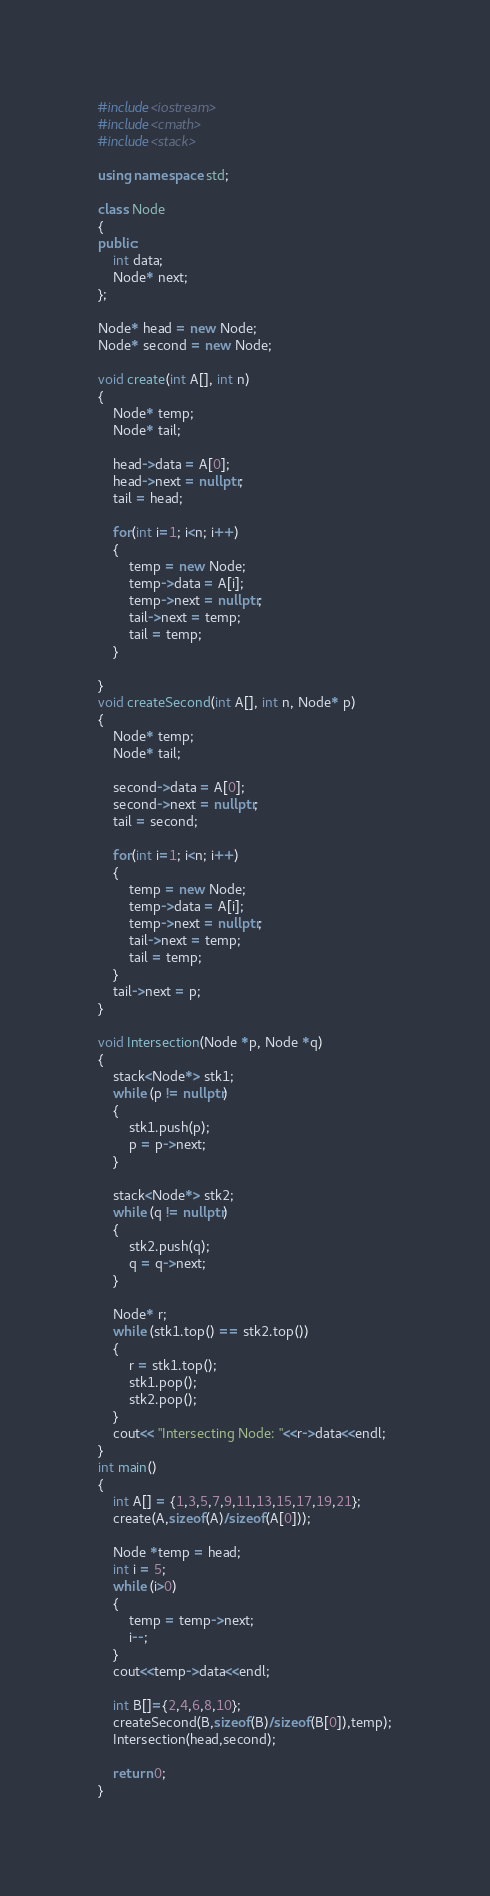<code> <loc_0><loc_0><loc_500><loc_500><_C++_>#include<iostream>
#include<cmath>
#include<stack>

using namespace std;

class Node
{
public:
    int data;
    Node* next;
};

Node* head = new Node;
Node* second = new Node;

void create(int A[], int n)
{
    Node* temp;
    Node* tail;

    head->data = A[0];
    head->next = nullptr;
    tail = head;

    for(int i=1; i<n; i++)
    {
        temp = new Node;
        temp->data = A[i];
        temp->next = nullptr;
        tail->next = temp;
        tail = temp;
    }
    
}
void createSecond(int A[], int n, Node* p)
{
    Node* temp;
    Node* tail;

    second->data = A[0];
    second->next = nullptr;
    tail = second;

    for(int i=1; i<n; i++)
    {
        temp = new Node;
        temp->data = A[i];
        temp->next = nullptr;
        tail->next = temp;
        tail = temp;
    }
    tail->next = p;
}

void Intersection(Node *p, Node *q)
{
    stack<Node*> stk1;
    while (p != nullptr)
    {
        stk1.push(p);
        p = p->next;
    }

    stack<Node*> stk2;
    while (q != nullptr)
    {
        stk2.push(q);
        q = q->next;
    }

    Node* r;
    while (stk1.top() == stk2.top())
    {
        r = stk1.top();
        stk1.pop();
        stk2.pop();
    }
    cout<< "Intersecting Node: "<<r->data<<endl;
}
int main()
{
    int A[] = {1,3,5,7,9,11,13,15,17,19,21};
    create(A,sizeof(A)/sizeof(A[0]));

    Node *temp = head;
    int i = 5;
    while (i>0)
    {
        temp = temp->next;
        i--;
    }
    cout<<temp->data<<endl;

    int B[]={2,4,6,8,10};
    createSecond(B,sizeof(B)/sizeof(B[0]),temp);
    Intersection(head,second);
    
    return 0;
}</code> 